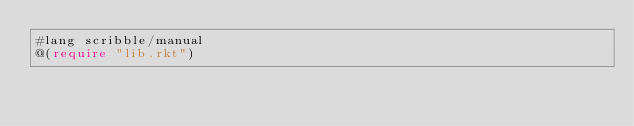Convert code to text. <code><loc_0><loc_0><loc_500><loc_500><_Racket_>#lang scribble/manual
@(require "lib.rkt")
</code> 